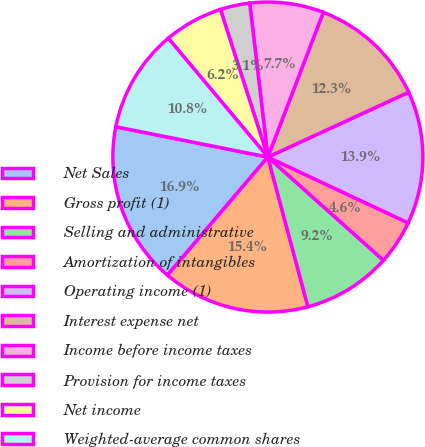Convert chart to OTSL. <chart><loc_0><loc_0><loc_500><loc_500><pie_chart><fcel>Net Sales<fcel>Gross profit (1)<fcel>Selling and administrative<fcel>Amortization of intangibles<fcel>Operating income (1)<fcel>Interest expense net<fcel>Income before income taxes<fcel>Provision for income taxes<fcel>Net income<fcel>Weighted-average common shares<nl><fcel>16.92%<fcel>15.38%<fcel>9.23%<fcel>4.62%<fcel>13.85%<fcel>12.31%<fcel>7.69%<fcel>3.08%<fcel>6.15%<fcel>10.77%<nl></chart> 